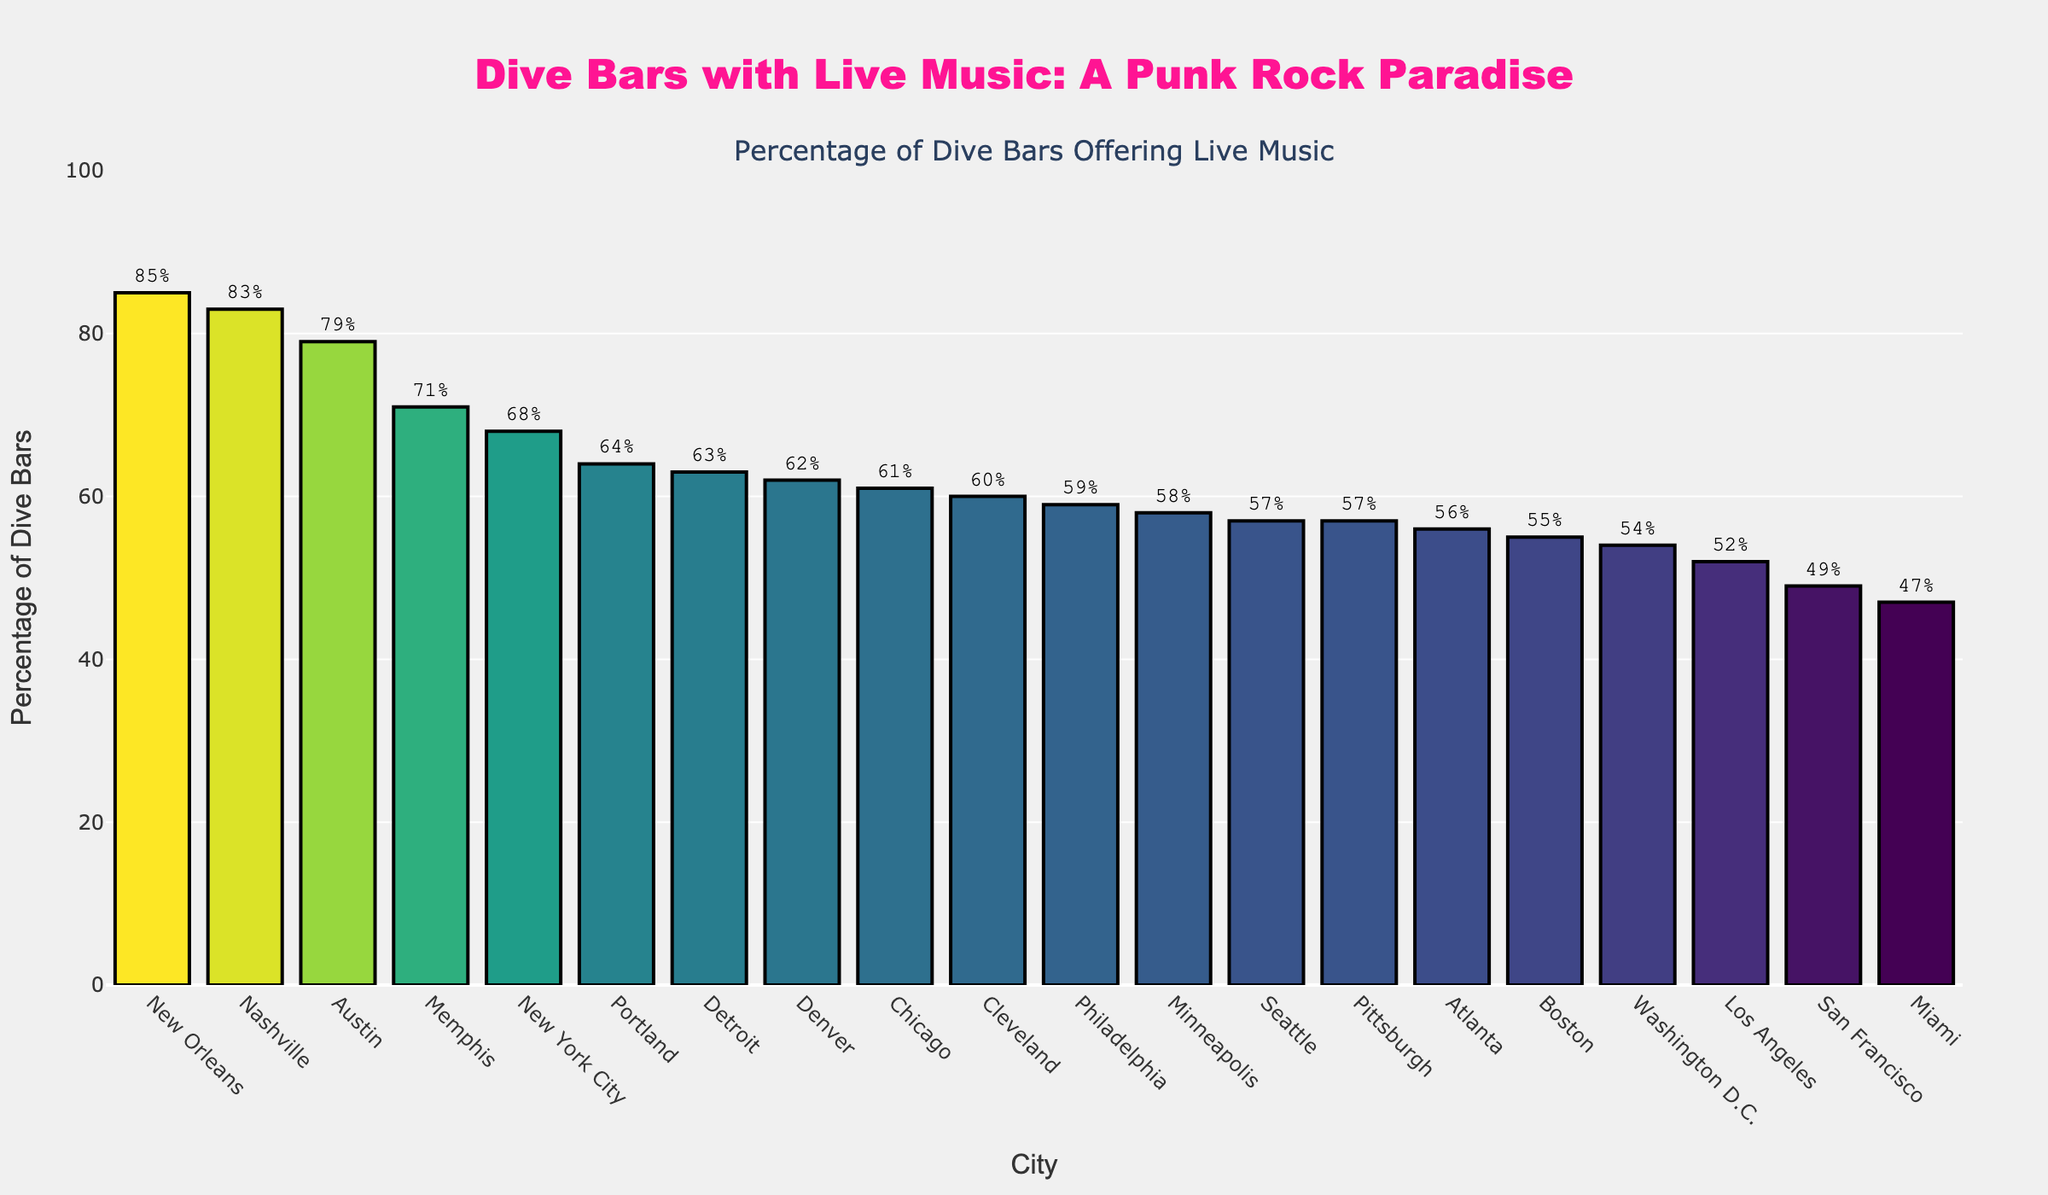Which city has the highest percentage of dive bars offering live music? The city with the highest bar in the chart represents the city with the highest percentage of dive bars offering live music. In this case, it's New Orleans.
Answer: New Orleans Which city has the lowest percentage of dive bars offering live music? The city with the shortest bar in the chart represents the city with the lowest percentage of dive bars offering live music. In this case, it's Miami.
Answer: Miami What is the percentage difference between Los Angeles and Boston? Find the percentage values for Los Angeles and Boston. Los Angeles is at 52% and Boston at 55%. Subtract the smaller percentage from the larger one: 55% - 52% = 3%.
Answer: 3% Which cities have percentages close to 60%? Look for cities with percentages around 60%. The cities close to 60% are Chicago (61%), Detroit (63%), Cleveland (60%), and Philadelphia (59%).
Answer: Chicago, Detroit, Cleveland, Philadelphia Is the percentage of dive bars offering live music in Austin higher than in San Francisco? Austin has a percentage of 79%, and San Francisco has a percentage of 49%. Since 79% is greater than 49%, Austin's percentage is indeed higher.
Answer: Yes What is the median percentage of dive bars offering live music across all cities? List all percentages in ascending order: 47, 49, 52, 54, 55, 56, 57, 57, 58, 59, 60, 61, 62, 63, 64, 68, 71, 79, 83, 85. With 20 cities, the median is the average of the 10th and 11th values: (59 + 60) / 2 = 59.5.
Answer: 59.5 Which city is more supportive of live music, Detroit or Pittsburgh? Detroit has a percentage of 63%, and Pittsburgh has a percentage of 57%. Since 63% is higher than 57%, Detroit is more supportive of live music.
Answer: Detroit How many cities have at least 70% of dive bars offering live music? Identify cities with percentages 70% or higher: New York City (68%), Nashville (83%), Austin (79%), New Orleans (85%), Memphis (71%). There are 4 such cities.
Answer: 4 Compare the percentage of dive bars offering live music in Seattle and Washington D.C. Seattle has 57% and Washington D.C. has 54%. Since 57% is greater than 54%, the percentage in Seattle is higher.
Answer: Seattle What is the average percentage of dive bars offering live music in the top 5 cities? List percentages of the top 5 cities: New Orleans (85%), Nashville (83%), Austin (79%), Memphis (71%), New York City (68%). Calculate the average: (85 + 83 + 79 + 71 + 68) / 5 = 77.2.
Answer: 77.2 